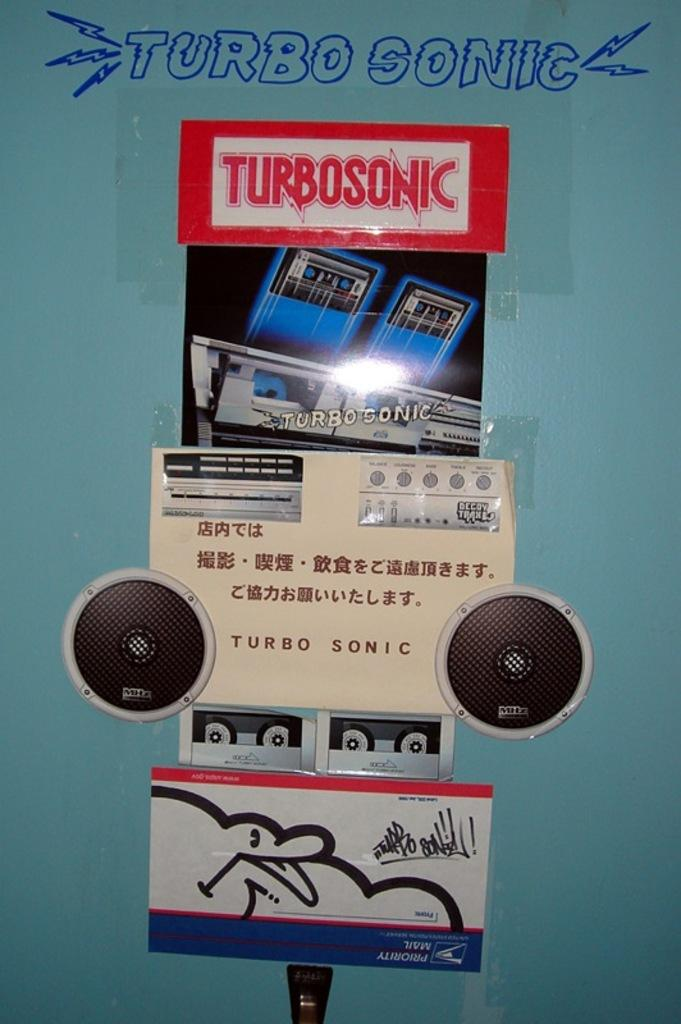<image>
Provide a brief description of the given image. A display called Turbosonic with pictures of cassettes and a stereo. 